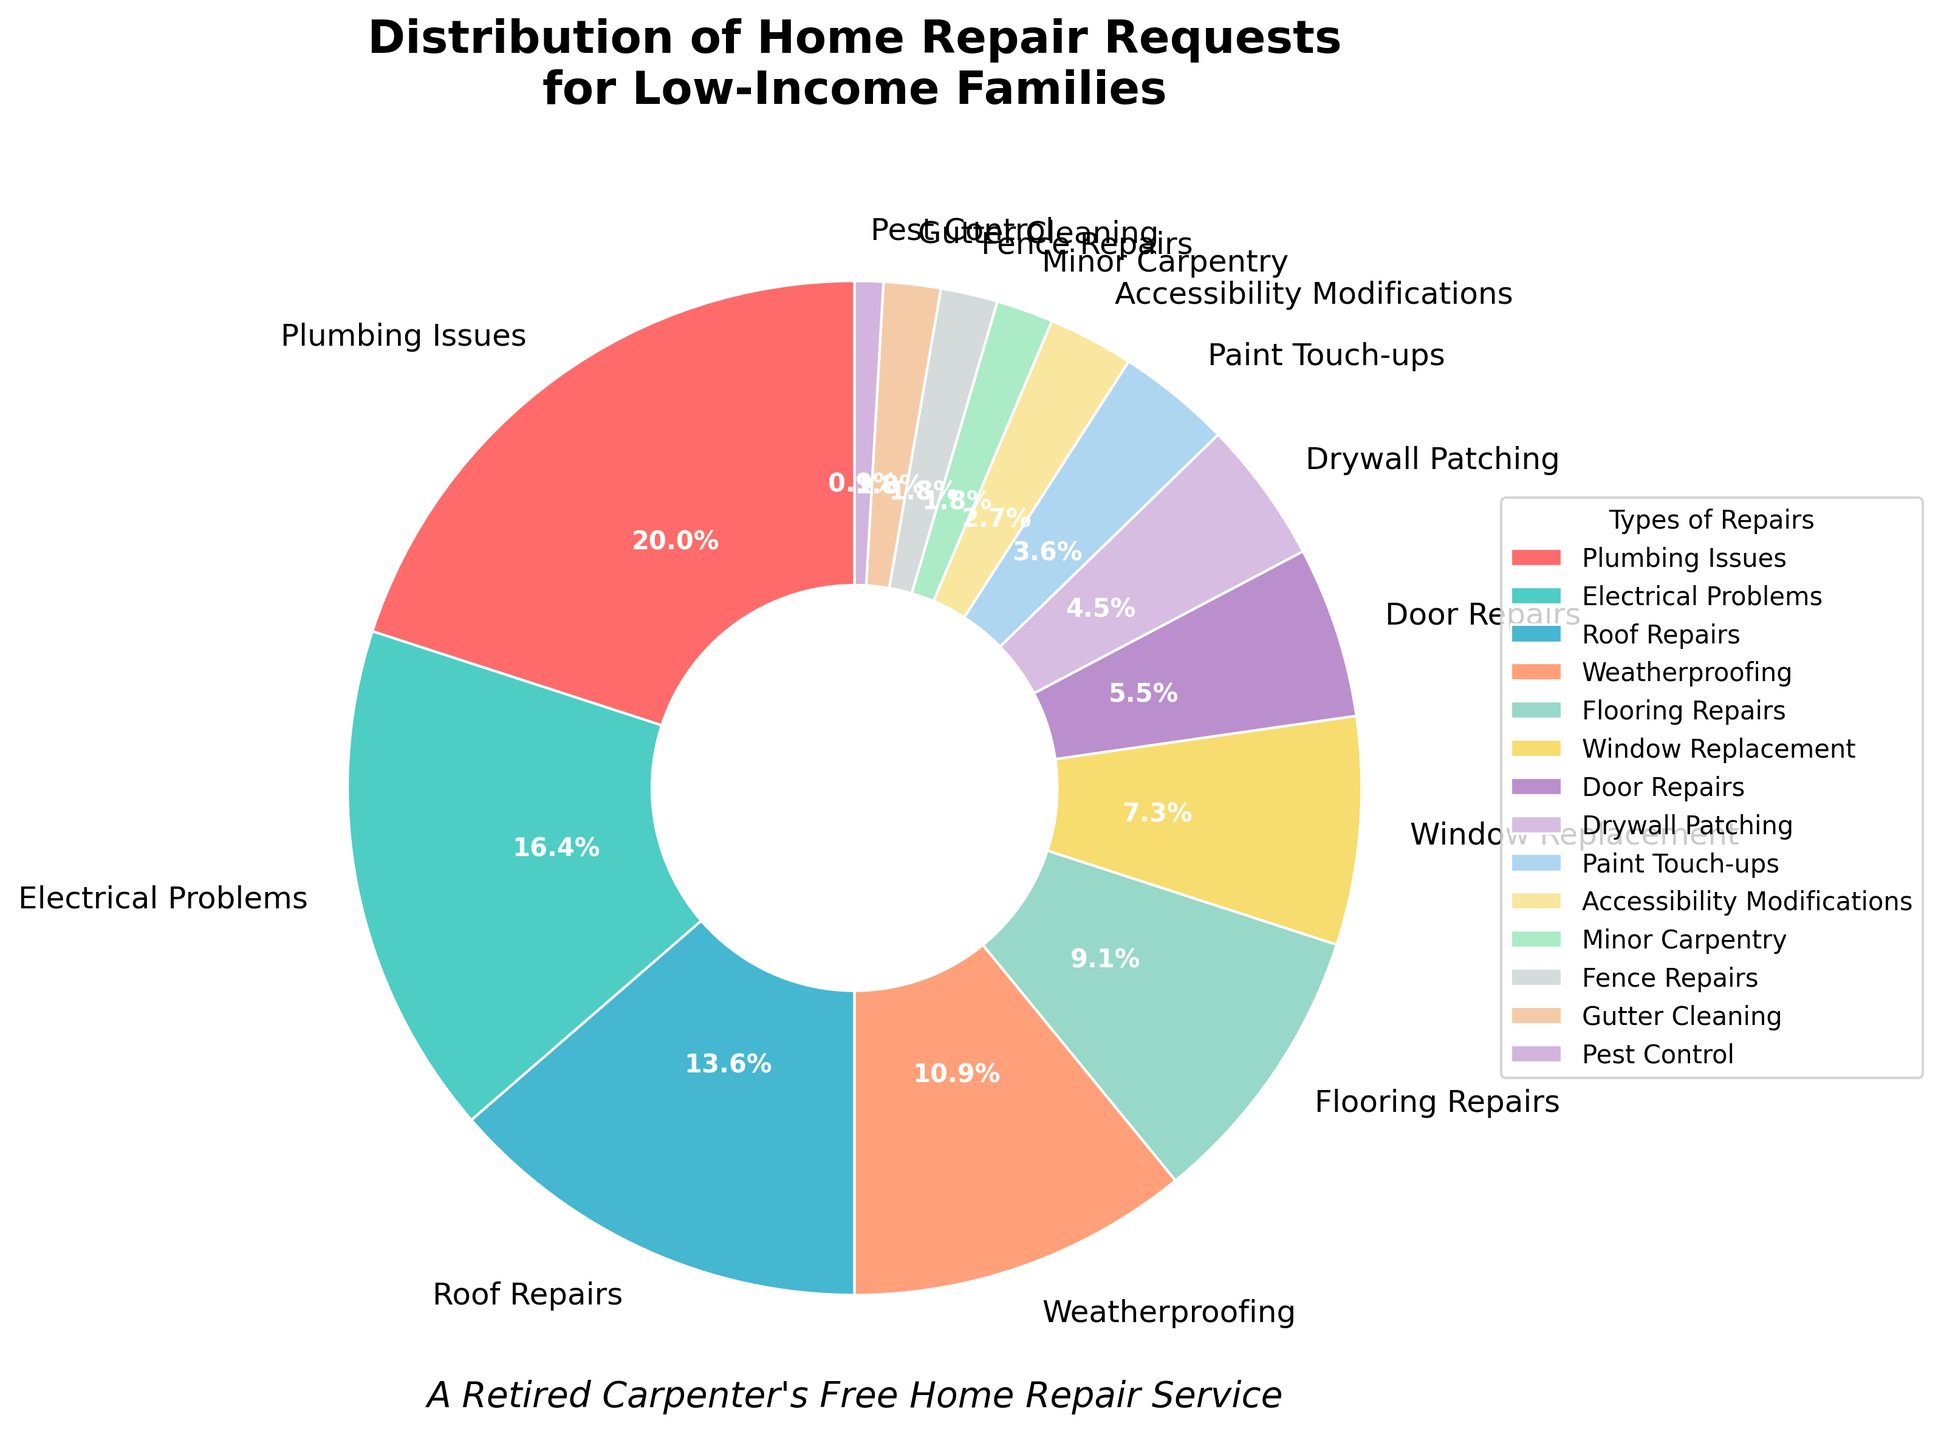What type of repair has the highest percentage of requests? "Plumbing Issues" has the highest percentage, representing 22% of the total requests.
Answer: Plumbing Issues Which type of repair has the lowest percentage of requests? "Pest Control" has the lowest percentage at just 1% of the total requests.
Answer: Pest Control What is the combined percentage of "Plumbing Issues" and "Electrical Problems"? Add the percentages for "Plumbing Issues" (22%) and "Electrical Problems" (18%). 22% + 18% = 40%.
Answer: 40% Is the percentage of requests for "Roof Repairs" less than those for "Electrical Problems"? "Roof Repairs" is 15% and "Electrical Problems" is 18%. Since 15% < 18%, "Roof Repairs" indeed has a smaller percentage.
Answer: Yes How many types of repairs have a percentage less than or equal to 5%? Identify the types with percentages ≤ 5%. They are "Drywall Patching" (5%), "Paint Touch-ups" (4%), "Accessibility Modifications" (3%), "Minor Carpentry" (2%), "Fence Repairs" (2%), "Gutter Cleaning" (2%), and "Pest Control" (1%), totaling 7 types.
Answer: 7 types Which type of repair has a percentage closest to 10%? "Flooring Repairs" has a percentage exactly at 10%, making it the closest to 10%.
Answer: Flooring Repairs Are there more requests for "Window Replacement" or "Door Repairs"? "Window Replacement" has 8% and "Door Repairs" has 6%. Since 8% > 6%, "Window Replacement" has more requests.
Answer: Window Replacement What is the average percentage of "Weatherproofing," "Flooring Repairs," and "Window Replacement"? Sum their percentages: 12% (Weatherproofing) + 10% (Flooring Repairs) + 8% (Window Replacement) = 30%. Then divide by the number of types (3). 30% / 3 = 10%.
Answer: 10% How many types of repairs have a percentage higher than 10%? Identify types with percentages > 10%. They are "Plumbing Issues" (22%), "Electrical Problems" (18%), "Roof Repairs" (15%), and "Weatherproofing" (12%), totaling 4 types.
Answer: 4 types What is the percentage difference between "Door Repairs" and "Drywall Patching"? Subtract the percentages: "Drywall Patching" (5%) - "Door Repairs" (6%) = 1%.
Answer: 1% 